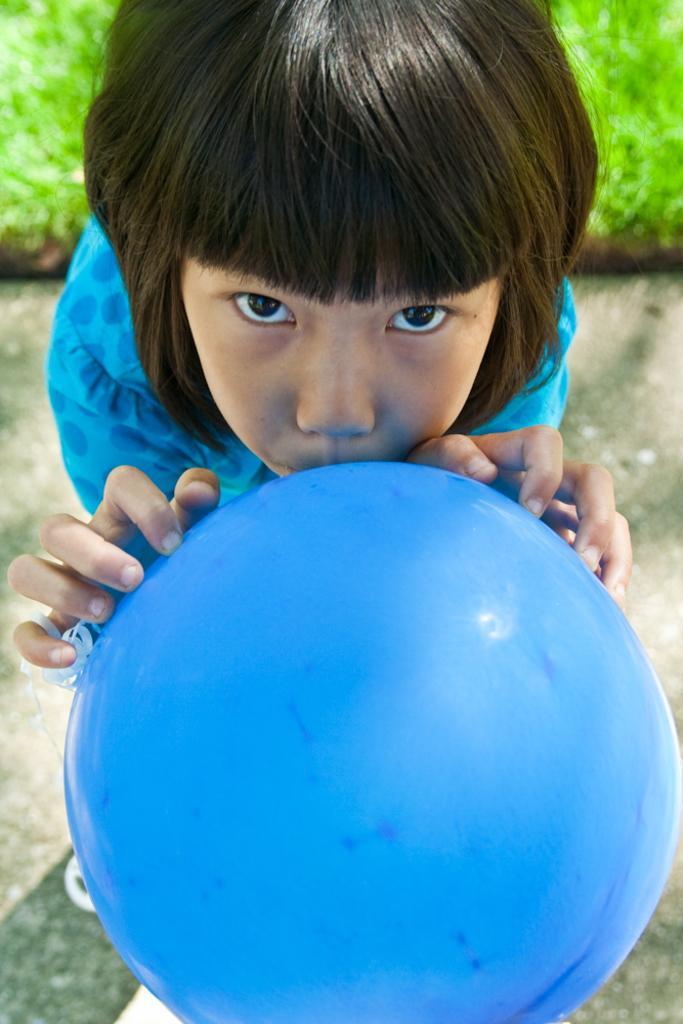How would you summarize this image in a sentence or two? In this image we can see there is a person standing on the ground and holding a ball. Grass in the background.. 